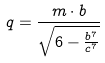Convert formula to latex. <formula><loc_0><loc_0><loc_500><loc_500>q = \frac { m \cdot b } { \sqrt { 6 - \frac { b ^ { 7 } } { c ^ { 7 } } } }</formula> 